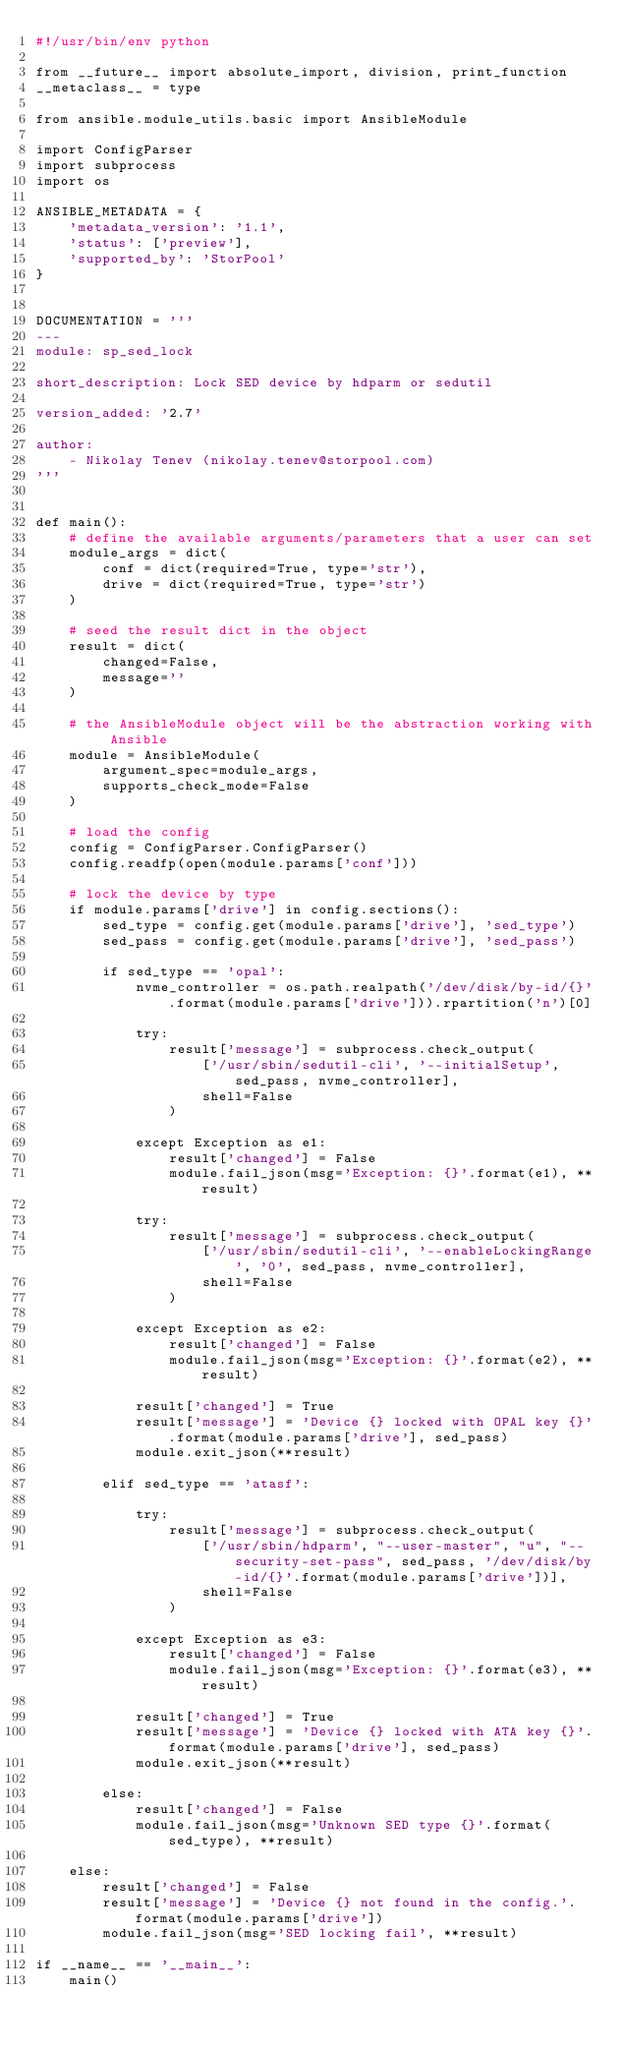<code> <loc_0><loc_0><loc_500><loc_500><_Python_>#!/usr/bin/env python

from __future__ import absolute_import, division, print_function
__metaclass__ = type

from ansible.module_utils.basic import AnsibleModule

import ConfigParser
import subprocess
import os

ANSIBLE_METADATA = {
    'metadata_version': '1.1',
    'status': ['preview'],
    'supported_by': 'StorPool'
}


DOCUMENTATION = '''
---
module: sp_sed_lock

short_description: Lock SED device by hdparm or sedutil

version_added: '2.7'

author:
    - Nikolay Tenev (nikolay.tenev@storpool.com)
'''


def main():
    # define the available arguments/parameters that a user can set
    module_args = dict(
        conf = dict(required=True, type='str'),
        drive = dict(required=True, type='str')
    )

    # seed the result dict in the object
    result = dict(
        changed=False,
        message=''
    )

    # the AnsibleModule object will be the abstraction working with Ansible
    module = AnsibleModule(
        argument_spec=module_args,
        supports_check_mode=False
    )

    # load the config
    config = ConfigParser.ConfigParser()
    config.readfp(open(module.params['conf']))

    # lock the device by type
    if module.params['drive'] in config.sections():
        sed_type = config.get(module.params['drive'], 'sed_type')
        sed_pass = config.get(module.params['drive'], 'sed_pass')

        if sed_type == 'opal':
            nvme_controller = os.path.realpath('/dev/disk/by-id/{}'.format(module.params['drive'])).rpartition('n')[0]

            try:
                result['message'] = subprocess.check_output(
                    ['/usr/sbin/sedutil-cli', '--initialSetup', sed_pass, nvme_controller],
                    shell=False
                )

            except Exception as e1:
                result['changed'] = False
                module.fail_json(msg='Exception: {}'.format(e1), **result)

            try:
                result['message'] = subprocess.check_output(
                    ['/usr/sbin/sedutil-cli', '--enableLockingRange', '0', sed_pass, nvme_controller],
                    shell=False
                )

            except Exception as e2:
                result['changed'] = False
                module.fail_json(msg='Exception: {}'.format(e2), **result)

            result['changed'] = True
            result['message'] = 'Device {} locked with OPAL key {}'.format(module.params['drive'], sed_pass)
            module.exit_json(**result)

        elif sed_type == 'atasf':

            try:
                result['message'] = subprocess.check_output(
                    ['/usr/sbin/hdparm', "--user-master", "u", "--security-set-pass", sed_pass, '/dev/disk/by-id/{}'.format(module.params['drive'])],
                    shell=False
                )

            except Exception as e3:
                result['changed'] = False
                module.fail_json(msg='Exception: {}'.format(e3), **result)

            result['changed'] = True
            result['message'] = 'Device {} locked with ATA key {}'.format(module.params['drive'], sed_pass)
            module.exit_json(**result)

        else:
            result['changed'] = False
            module.fail_json(msg='Unknown SED type {}'.format(sed_type), **result)

    else:
        result['changed'] = False
        result['message'] = 'Device {} not found in the config.'.format(module.params['drive'])
        module.fail_json(msg='SED locking fail', **result)

if __name__ == '__main__':
    main()
</code> 